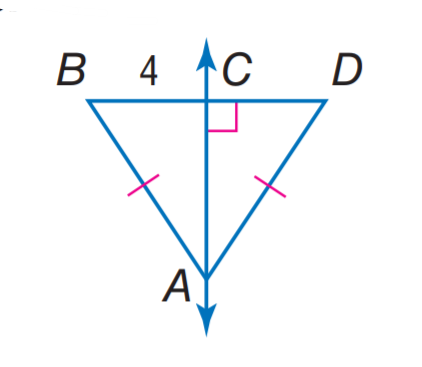Answer the mathemtical geometry problem and directly provide the correct option letter.
Question: Find C D.
Choices: A: 2 B: 4 C: 8 D: 12 B 